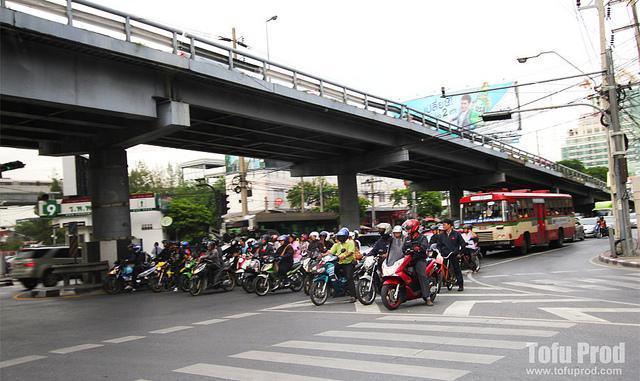How many buses can you see?
Give a very brief answer. 2. How many airplanes are there flying in the photo?
Give a very brief answer. 0. 